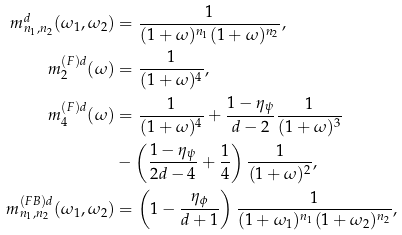<formula> <loc_0><loc_0><loc_500><loc_500>m ^ { d } _ { n _ { 1 } , n _ { 2 } } ( \omega _ { 1 } , \omega _ { 2 } ) & = \frac { 1 } { ( 1 + \omega ) ^ { n _ { 1 } } ( 1 + \omega ) ^ { n _ { 2 } } } , \\ m ^ { ( F ) d } _ { 2 } ( \omega ) & = \frac { 1 } { ( 1 + \omega ) ^ { 4 } } , \\ m ^ { ( F ) d } _ { 4 } ( \omega ) & = \frac { 1 } { ( 1 + \omega ) ^ { 4 } } + \frac { 1 - \eta _ { \psi } } { d - 2 } \frac { 1 } { ( 1 + \omega ) ^ { 3 } } \\ & - \left ( \frac { 1 - \eta _ { \psi } } { 2 d - 4 } + \frac { 1 } { 4 } \right ) \frac { 1 } { ( 1 + \omega ) ^ { 2 } } , \\ m ^ { ( F B ) d } _ { n _ { 1 } , n _ { 2 } } ( \omega _ { 1 } , \omega _ { 2 } ) & = \left ( 1 - \frac { \eta _ { \phi } } { d + 1 } \right ) \frac { 1 } { ( 1 + \omega _ { 1 } ) ^ { n _ { 1 } } ( 1 + \omega _ { 2 } ) ^ { n _ { 2 } } } ,</formula> 